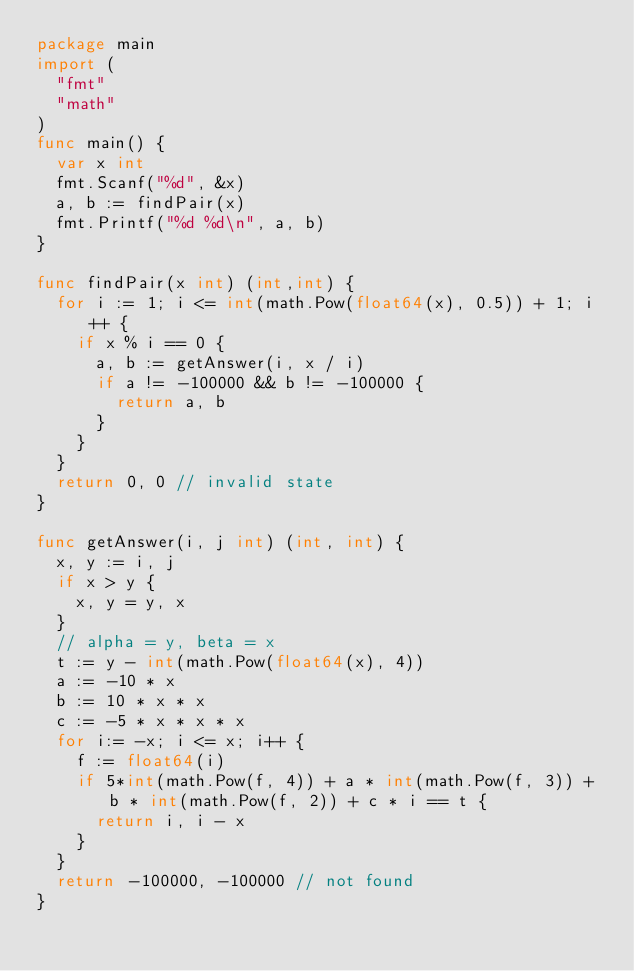<code> <loc_0><loc_0><loc_500><loc_500><_Go_>package main
import (
	"fmt"
	"math"
)
func main() {
	var x int
	fmt.Scanf("%d", &x)
	a, b := findPair(x)
	fmt.Printf("%d %d\n", a, b)
}

func findPair(x int) (int,int) {
	for i := 1; i <= int(math.Pow(float64(x), 0.5)) + 1; i ++ {
		if x % i == 0 {
			a, b := getAnswer(i, x / i)
			if a != -100000 && b != -100000 {
				return a, b
			}
		}
	} 
	return 0, 0 // invalid state
}

func getAnswer(i, j int) (int, int) {
	x, y := i, j
	if x > y {
		x, y = y, x
	}
	// alpha = y, beta = x
	t := y - int(math.Pow(float64(x), 4))
	a := -10 * x
	b := 10 * x * x
	c := -5 * x * x * x
	for i:= -x; i <= x; i++ {
		f := float64(i)
		if 5*int(math.Pow(f, 4)) + a * int(math.Pow(f, 3)) + b * int(math.Pow(f, 2)) + c * i == t {
			return i, i - x
		}
	}
	return -100000, -100000 // not found
}</code> 